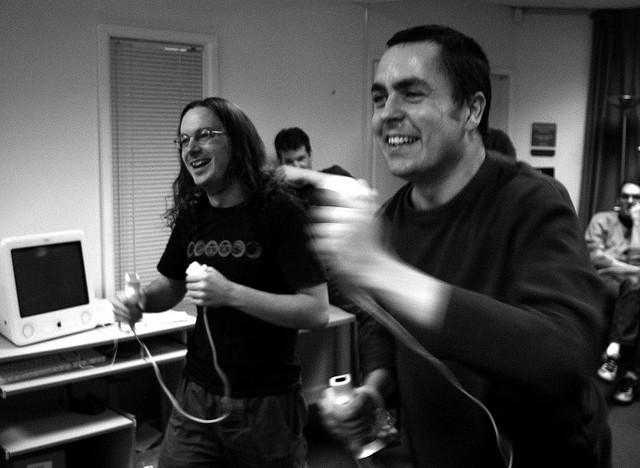What should be installed on the device with a screen?

Choices:
A) operating system
B) oil line
C) vice
D) heater operating system 